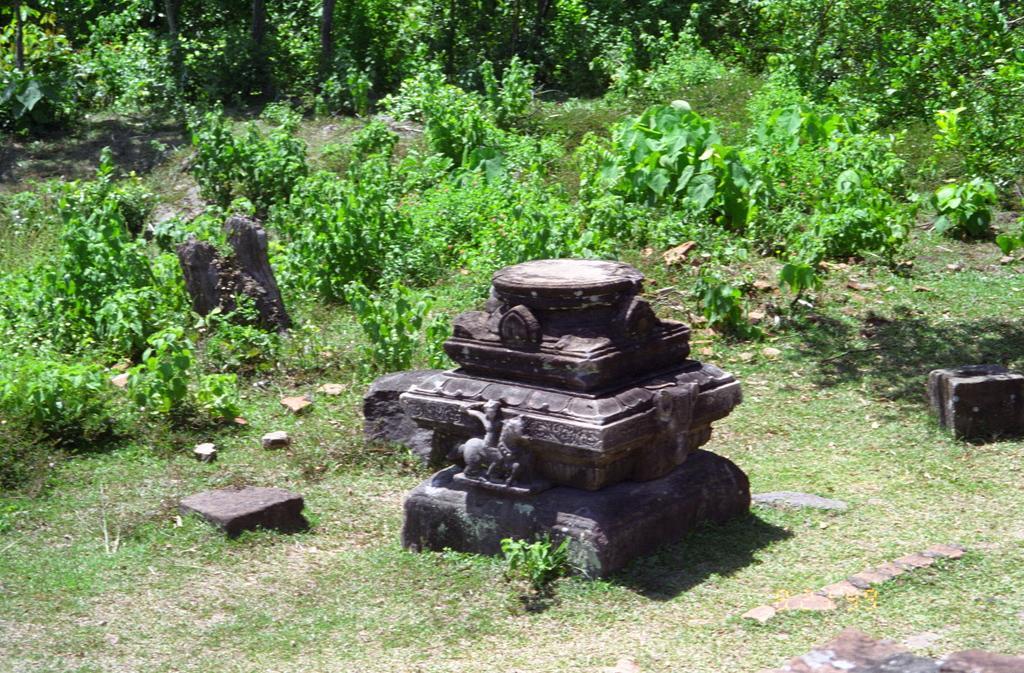In one or two sentences, can you explain what this image depicts? In the center of the image we can see a statue. In the background of the image we can see the plants, grass, tree trunk, stones. At the bottom of the image we can see the ground. 